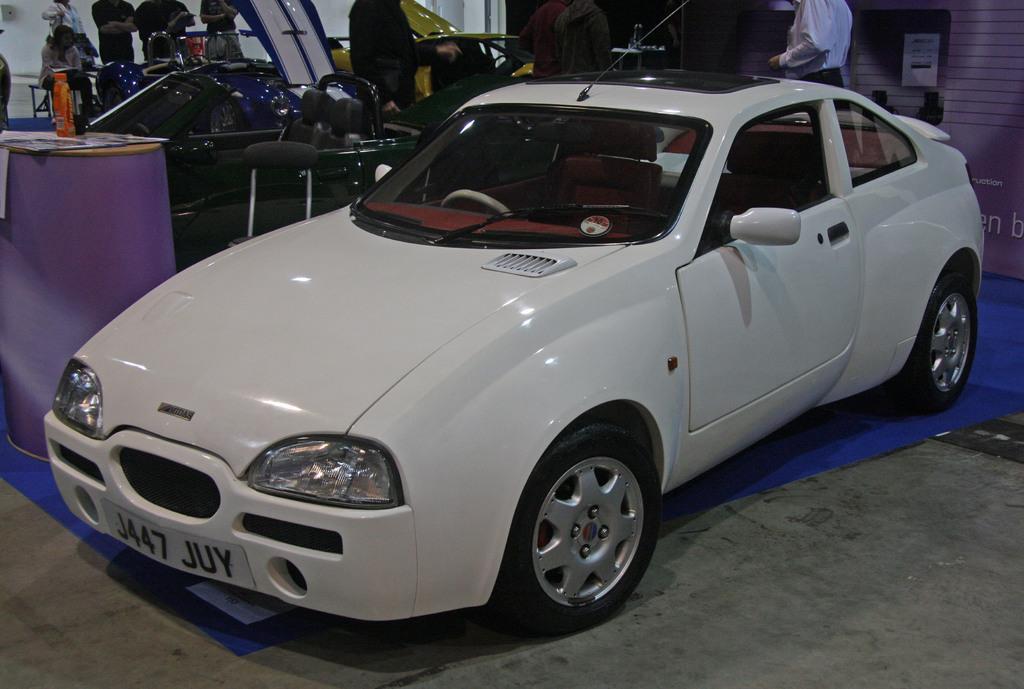Describe this image in one or two sentences. There is a white color car on a blue floor with a number plate. In the back there are many chairs. Some people are there. Also there is a wall. On the left side there is a stand. On that there are some things. And some people are standing in the back side. 